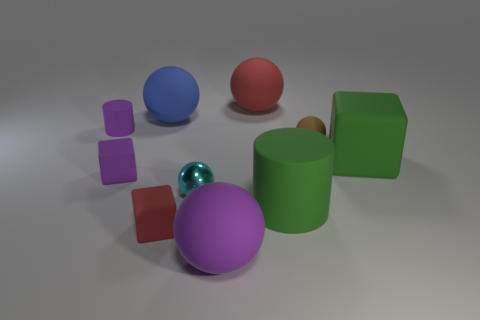Is there a tiny cube made of the same material as the large red thing?
Provide a succinct answer. Yes. What number of things are both left of the brown matte sphere and behind the purple ball?
Offer a terse response. 7. Is the number of large blue objects that are in front of the green cylinder less than the number of cyan shiny things that are behind the brown rubber ball?
Your response must be concise. No. Do the large purple thing and the small metallic thing have the same shape?
Make the answer very short. Yes. How many other objects are there of the same size as the red sphere?
Ensure brevity in your answer.  4. How many objects are either large objects that are left of the brown rubber object or cylinders to the left of the big blue ball?
Offer a terse response. 5. How many other metallic objects have the same shape as the blue thing?
Keep it short and to the point. 1. What material is the sphere that is to the left of the big purple sphere and behind the tiny cylinder?
Ensure brevity in your answer.  Rubber. What number of red rubber objects are behind the green block?
Make the answer very short. 1. What number of purple metal balls are there?
Give a very brief answer. 0. 